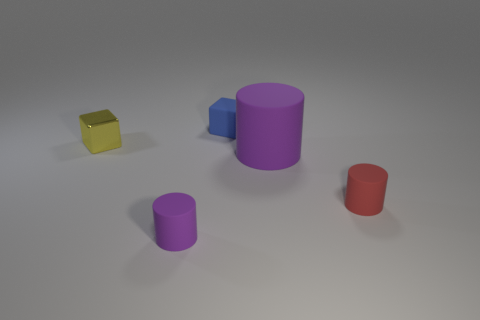Add 3 tiny purple things. How many objects exist? 8 Subtract all cylinders. How many objects are left? 2 Add 2 small red rubber things. How many small red rubber things are left? 3 Add 5 small purple objects. How many small purple objects exist? 6 Subtract 0 gray balls. How many objects are left? 5 Subtract all big green balls. Subtract all tiny red objects. How many objects are left? 4 